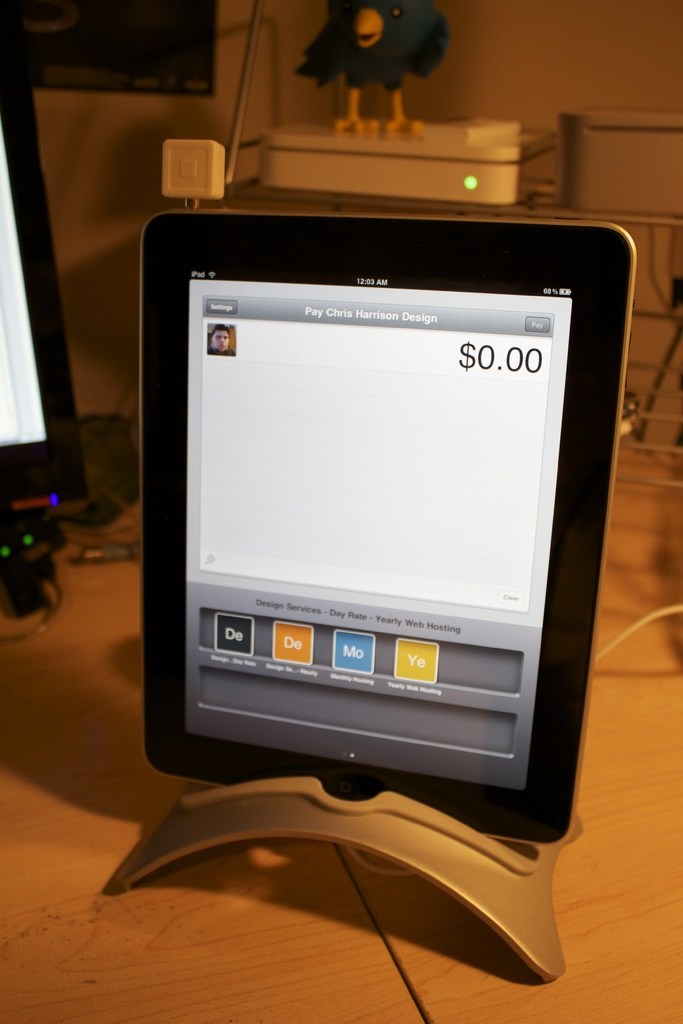Provide a one-sentence caption for the provided image. The image shows a budget-friendly digital payment interface on a tablet, with a prompt to pay Chris Harrison Design set at $0.00, and options for payments like daily, monthly, and yearly web hosting services. 